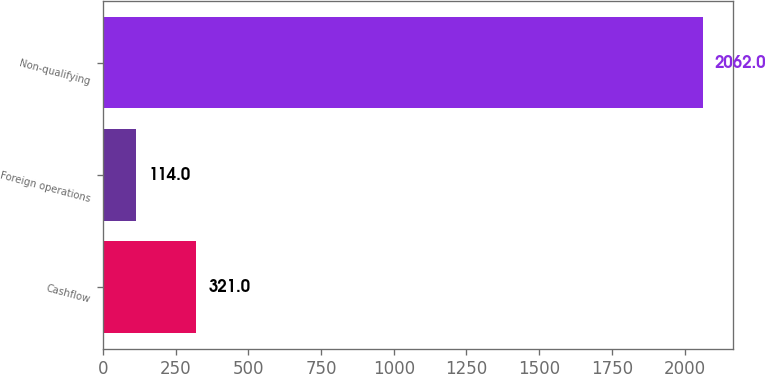<chart> <loc_0><loc_0><loc_500><loc_500><bar_chart><fcel>Cashflow<fcel>Foreign operations<fcel>Non-qualifying<nl><fcel>321<fcel>114<fcel>2062<nl></chart> 